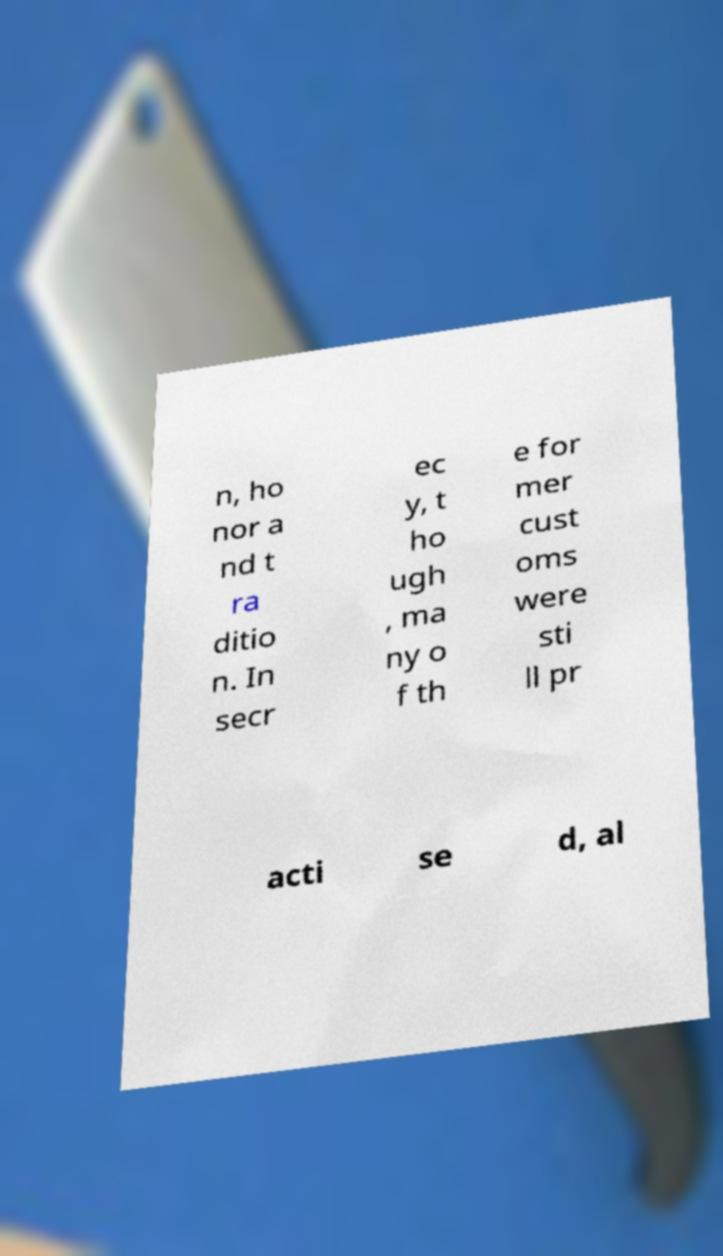Please read and relay the text visible in this image. What does it say? n, ho nor a nd t ra ditio n. In secr ec y, t ho ugh , ma ny o f th e for mer cust oms were sti ll pr acti se d, al 